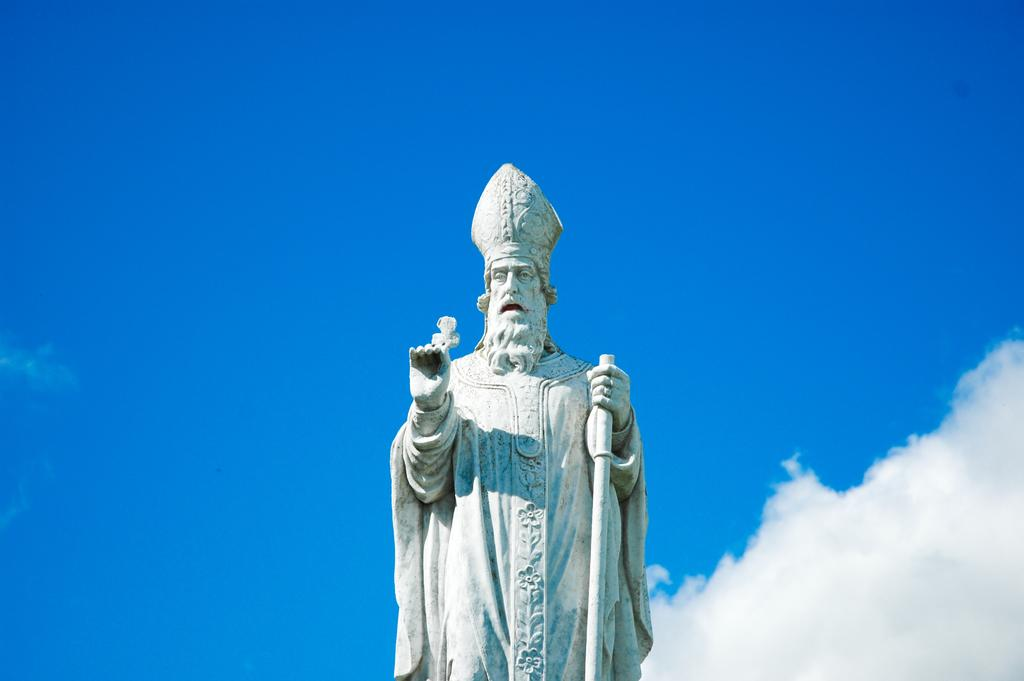What is the color of the statue in the image? The statue in the image is white. What is the color of the sky in the image? The sky in the image is blue. Are there any additional features in the sky besides the blue color? Yes, clouds are present in the sky. What type of furniture can be seen inside the cave in the image? There is no cave or furniture present in the image; it features a white statue and a blue sky with clouds. 